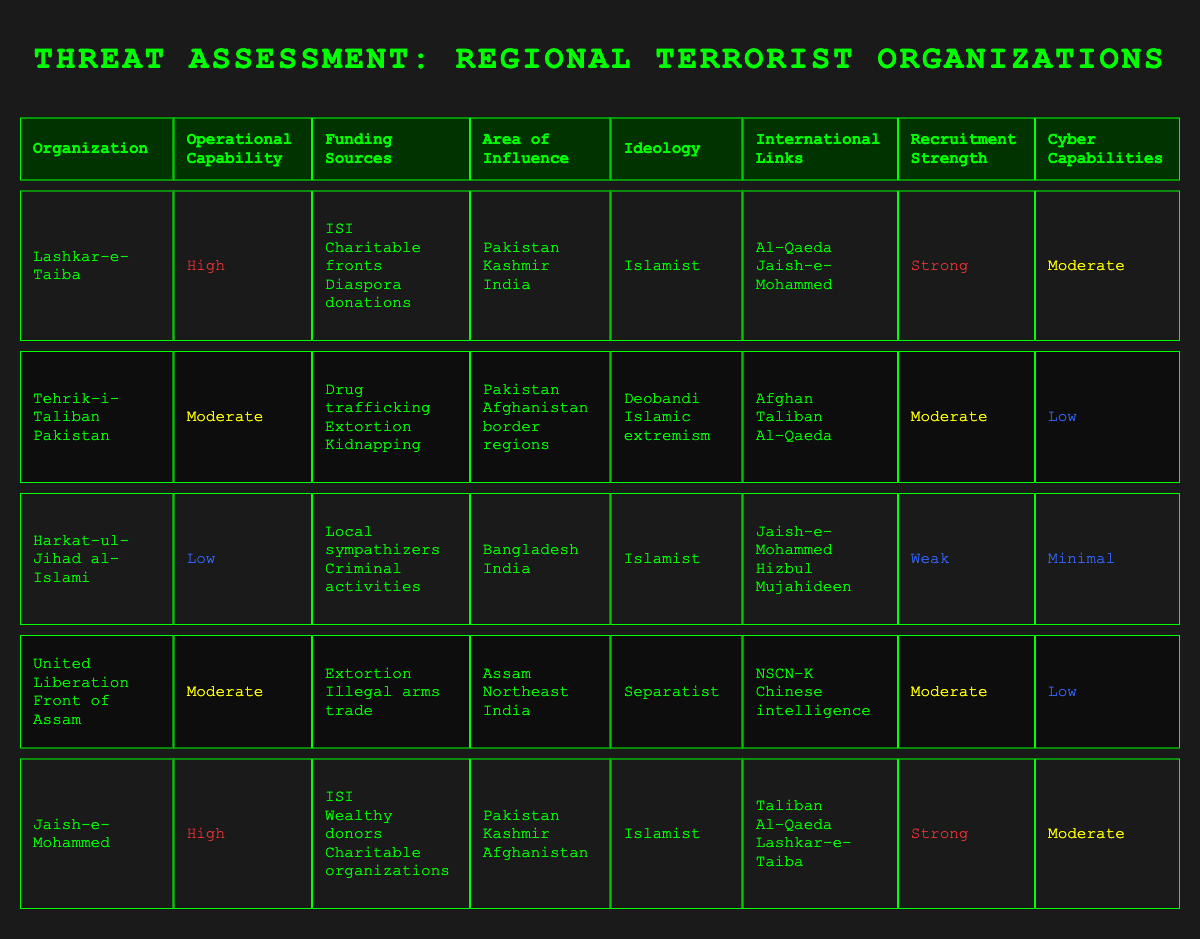What is the area of influence for Lashkar-e-Taiba? According to the table, the area of influence for Lashkar-e-Taiba includes Pakistan, Kashmir, and India.
Answer: Pakistan, Kashmir, India Which organization has a high operational capability? The organizations listed with high operational capability are Lashkar-e-Taiba and Jaish-e-Mohammed.
Answer: Lashkar-e-Taiba, Jaish-e-Mohammed What are the funding sources for Tehrik-i-Taliban Pakistan? The table states that Tehrik-i-Taliban Pakistan's funding sources include drug trafficking, extortion, and kidnapping.
Answer: Drug trafficking, extortion, kidnapping Is the recruitment strength of Harkat-ul-Jihad al-Islami strong? According to the table, Harkat-ul-Jihad al-Islami has a recruitment strength labeled as weak, indicating it is not strong.
Answer: No What is the average operational capability across all organizations listed? The operational capabilities classified are high, moderate, and low, which can be numerically represented as 3 (high), 2 (moderate), and 1 (low). This results in an average operational capability of (3*3 + 2*2 + 1*1) / 5 = 2.2, which rounds to moderate as the dominant classification.
Answer: Moderate Which organization has the weakest cyber capabilities? By examining the table, Harkat-ul-Jihad al-Islami has minimal cyber capabilities, which is the weakest among the organizations listed.
Answer: Harkat-ul-Jihad al-Islami How many organizations have international links with Al-Qaeda? The organizations that have international links with Al-Qaeda are Tehrik-i-Taliban Pakistan, Jaish-e-Mohammed, and Lashkar-e-Taiba. In total, 3 organizations are linked.
Answer: 3 If you sum the recruitment strengths of all organizations as high, moderate, and weak, what would that equate to numerically? Using a numerical scale of high=3, moderate=2, and weak=1, we summarize it as follows: Lashkar-e-Taiba (3), Tehrik-i-Taliban Pakistan (2), Harkat-ul-Jihad al-Islami (1), United Liberation Front of Assam (2), and Jaish-e-Mohammed (3). Sum = 3 + 2 + 1 + 2 + 3 = 11 for an average of 11/5 = 2.2, which corresponds to moderate.
Answer: Moderate What ideology is associated with United Liberation Front of Assam? The table indicates that the ideology associated with the United Liberation Front of Assam is separatist.
Answer: Separatist 